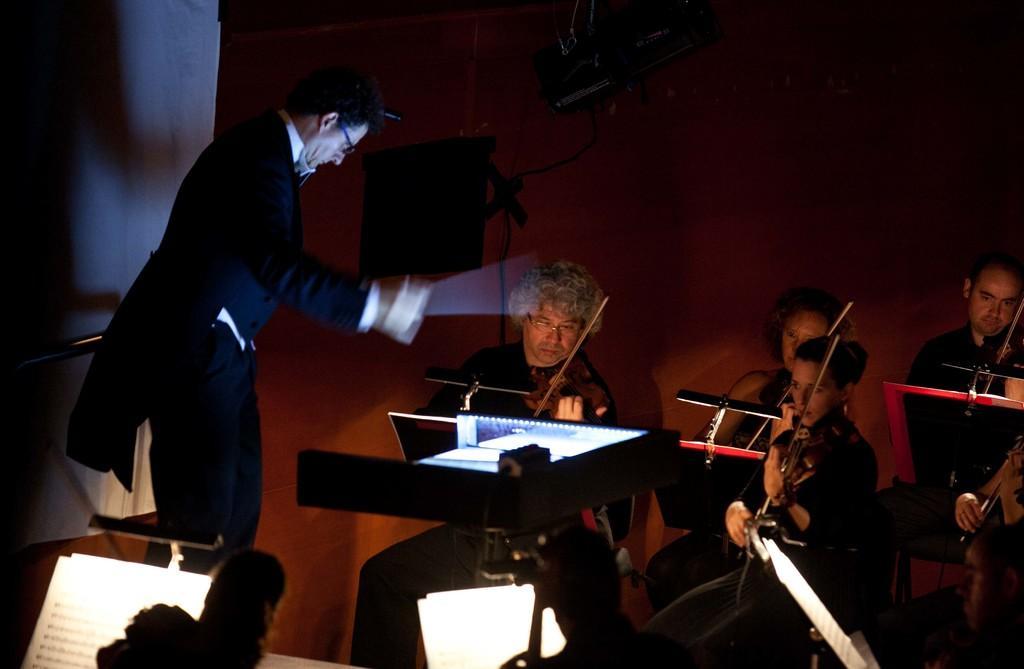In one or two sentences, can you explain what this image depicts? In this image I can see few people where everyone is sitting and holding a musical instruments and here I can see a man is standing. 